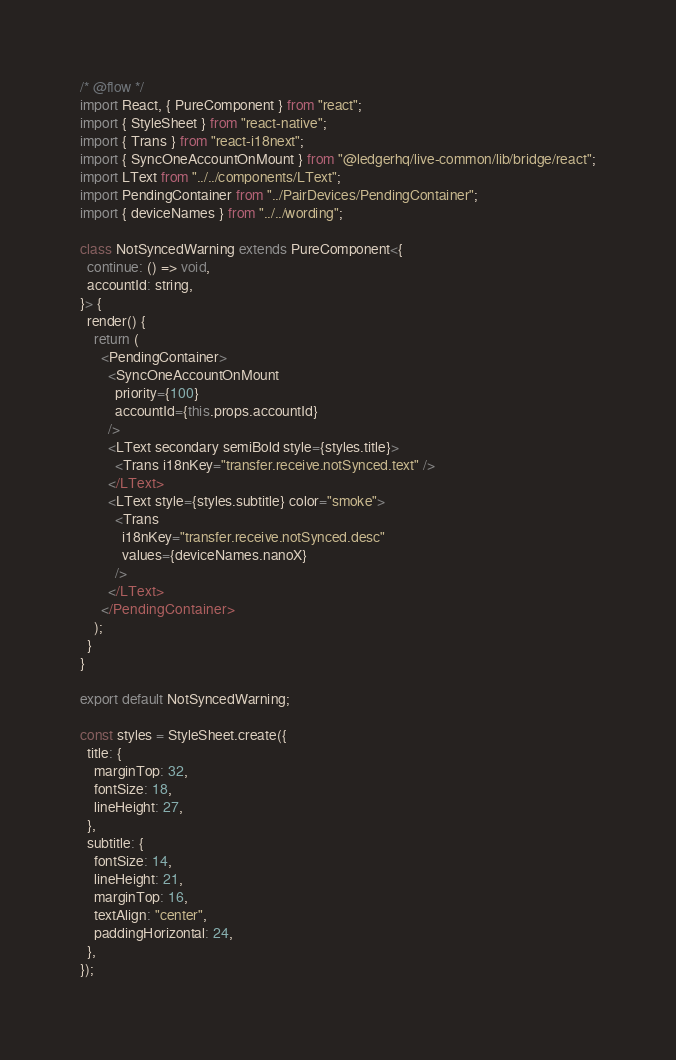<code> <loc_0><loc_0><loc_500><loc_500><_JavaScript_>/* @flow */
import React, { PureComponent } from "react";
import { StyleSheet } from "react-native";
import { Trans } from "react-i18next";
import { SyncOneAccountOnMount } from "@ledgerhq/live-common/lib/bridge/react";
import LText from "../../components/LText";
import PendingContainer from "../PairDevices/PendingContainer";
import { deviceNames } from "../../wording";

class NotSyncedWarning extends PureComponent<{
  continue: () => void,
  accountId: string,
}> {
  render() {
    return (
      <PendingContainer>
        <SyncOneAccountOnMount
          priority={100}
          accountId={this.props.accountId}
        />
        <LText secondary semiBold style={styles.title}>
          <Trans i18nKey="transfer.receive.notSynced.text" />
        </LText>
        <LText style={styles.subtitle} color="smoke">
          <Trans
            i18nKey="transfer.receive.notSynced.desc"
            values={deviceNames.nanoX}
          />
        </LText>
      </PendingContainer>
    );
  }
}

export default NotSyncedWarning;

const styles = StyleSheet.create({
  title: {
    marginTop: 32,
    fontSize: 18,
    lineHeight: 27,
  },
  subtitle: {
    fontSize: 14,
    lineHeight: 21,
    marginTop: 16,
    textAlign: "center",
    paddingHorizontal: 24,
  },
});
</code> 